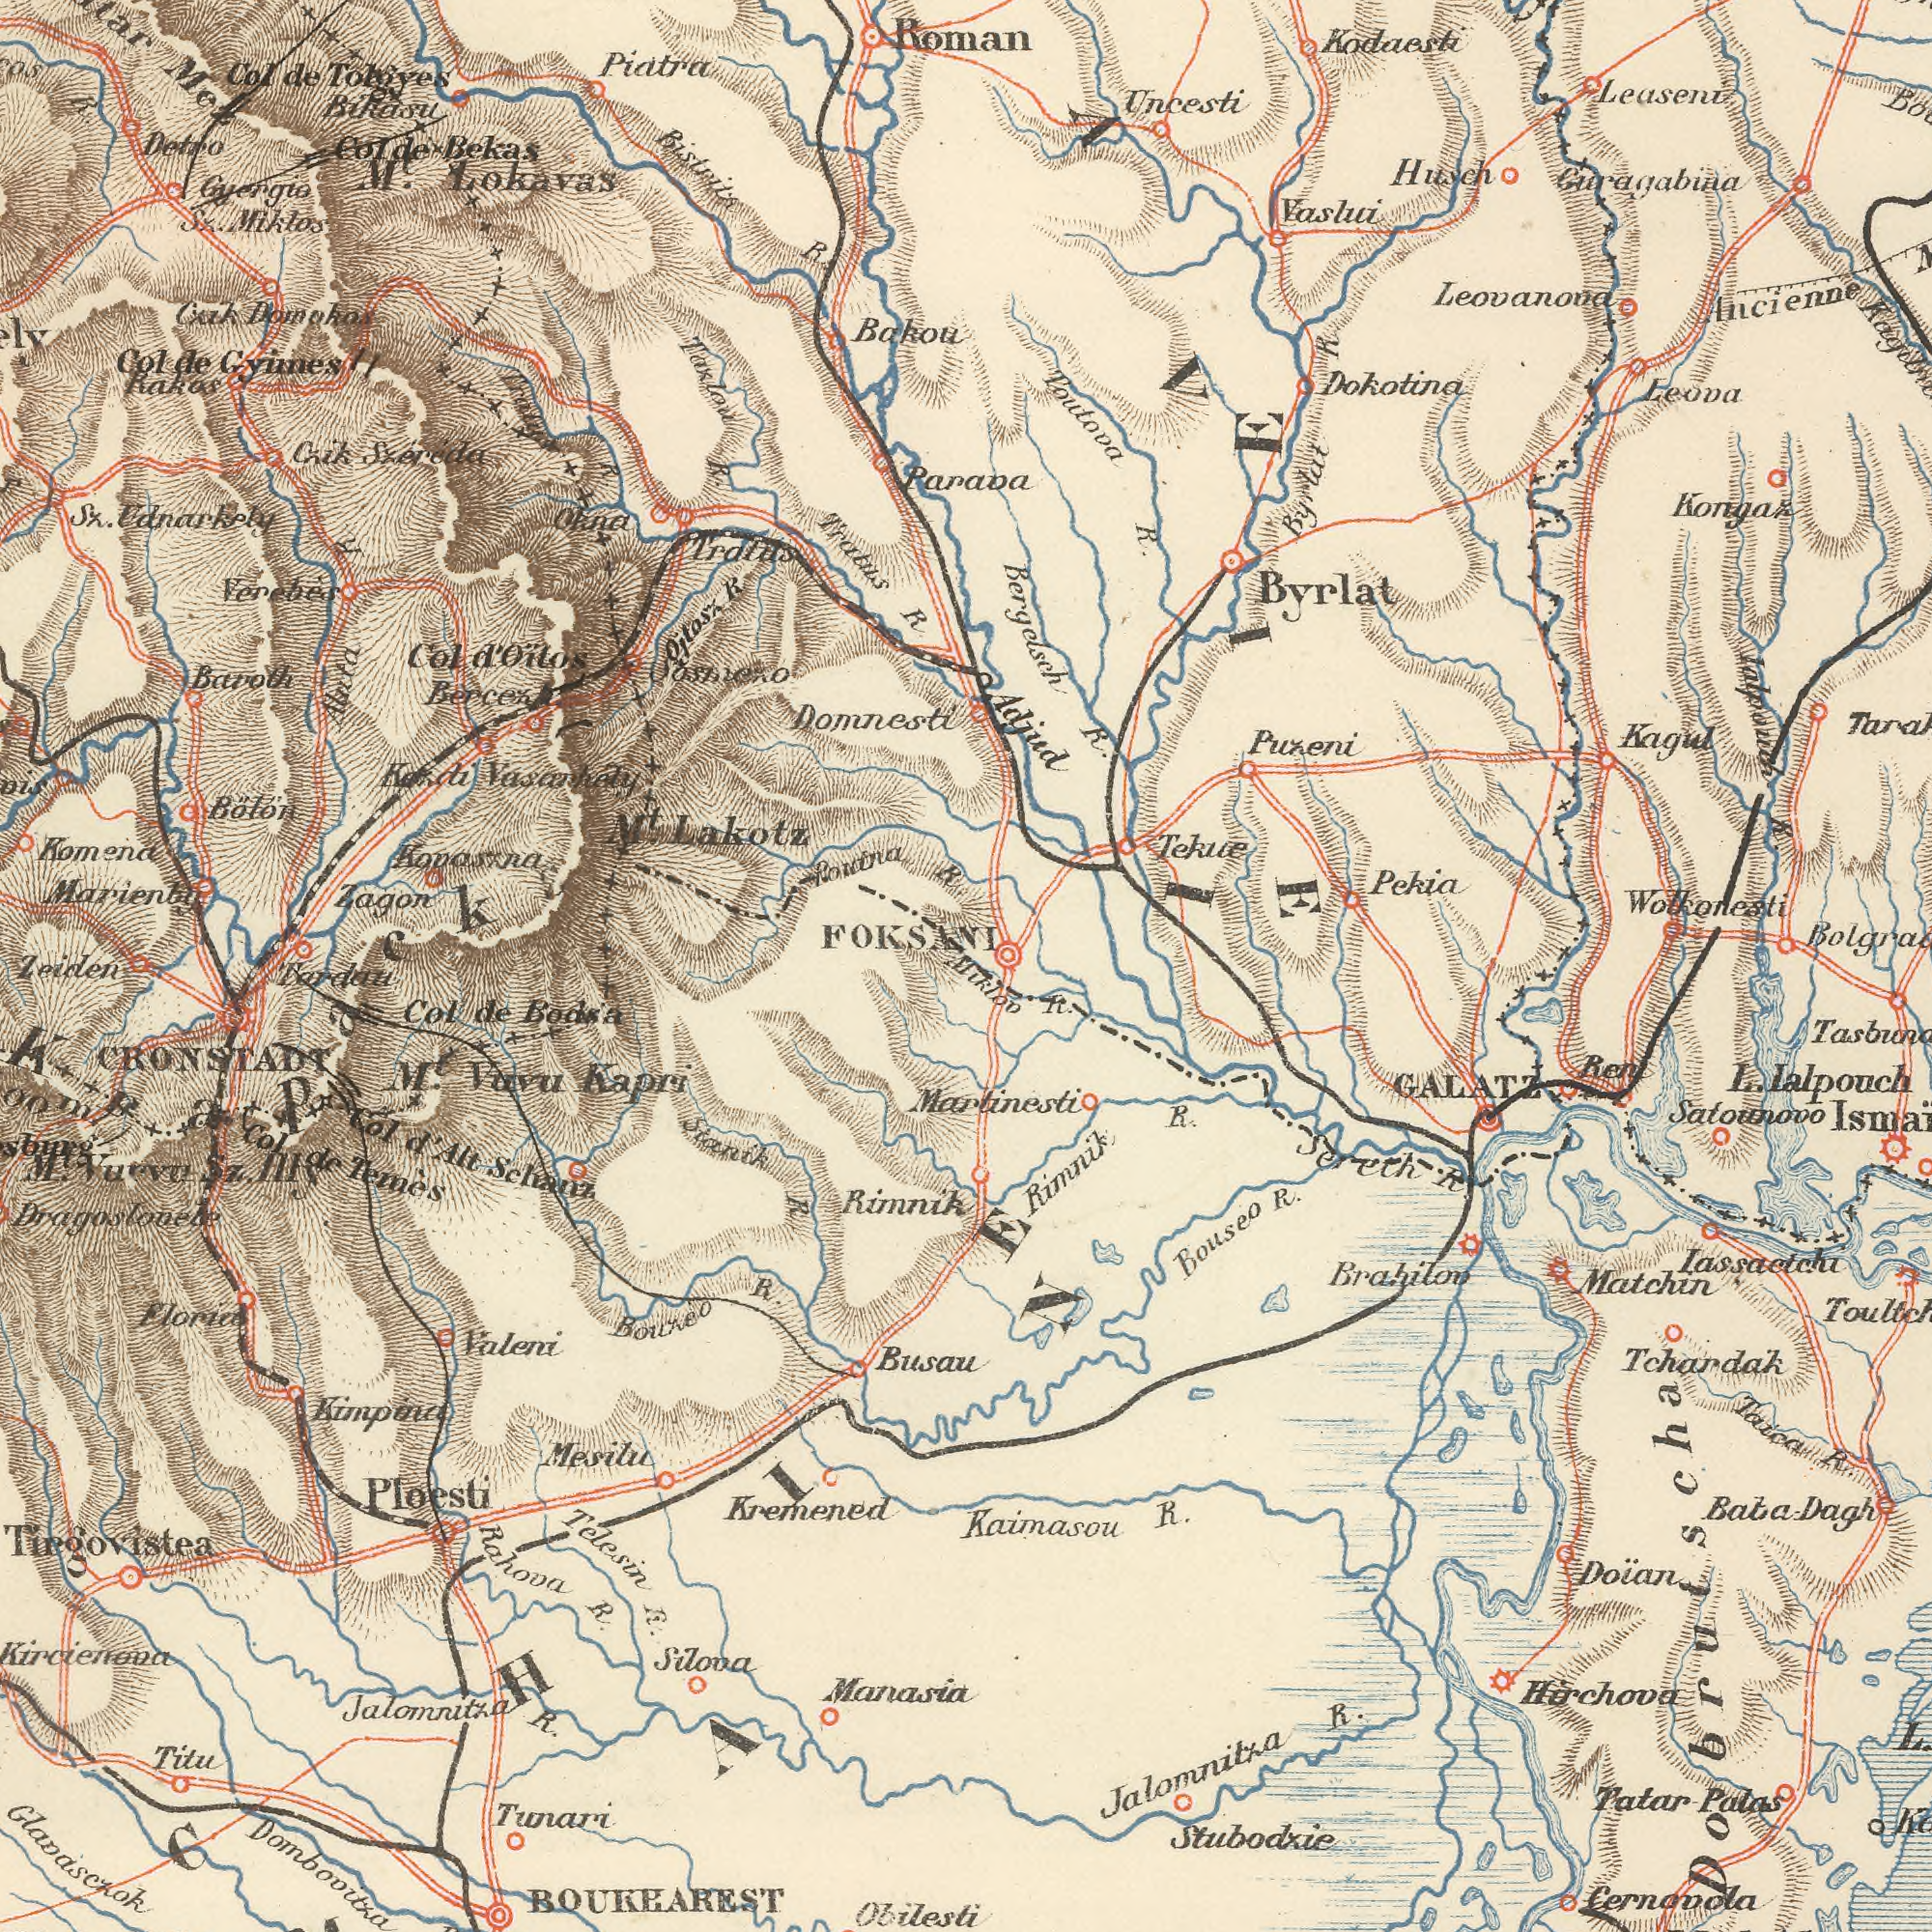What text appears in the top-left area of the image? M. Lokavas Domnesti Marienba Piatra Bőlőn Domoko Bikasu Kovasxna Tratus R. Czik Szèrèda Okna Col de Gyimes Detro Taklow R. Verebès Bistrita R Colde Bekas Col de Ronina R. R. Sz. Udnarkely Oitasx R. Baroth Gyergio Komena Tratus Zagon Mez Sz. Miklos Alnta R. Raker FOKSANI Bercez Kobdi Vasankdy Cold Oitos Bakou Oashien O R. M<sup>t</sup>. Lakotz Zeiden What text can you see in the bottom-right section? Stubodxie Kaimasou R. Tchardak Hirchova Satounovo Cernovola Matchin Tatar Patas Rimnik R. Bouseo R. Doїan Taica R. Jalomnitza R. L. Lalpouch Ren Miklon R. Sereth R. GALATZ Martinesti Lassactchi Brahilon Dobrutscha Bata Dagh What text can you see in the bottom-left section? Dombovitka Kremened Kircienona Rahova R. Stanik R. Telesin R. Jalomnitza R. Mesilu Ploesti Rimnik Silona Col d Alt Schanz Bouneo R. Col de Temés Manasia Mt<sup>t</sup>. Valu Kapri Col de Bodsa Valeni Tunari Busau Dragosloneke Glanasczok Tirgovistea Obilesti CRONSTADT Titu BOUKEAREST M. Vuevo Sz. Hig Lardau ###CHIE Krapack What text is shown in the top-right quadrant? Roman Paraoa Toutova R. Kodaesti Leaseni Dokotina Leovanova Uncesti Ancienne Kongaz Husch Bergdsch R. Leova Kagul Pekia Puzeni Vashui Byrlat Adjud Byrlat R. Tekue Wolkonesti Ialpouch R. Garagabina VIE 